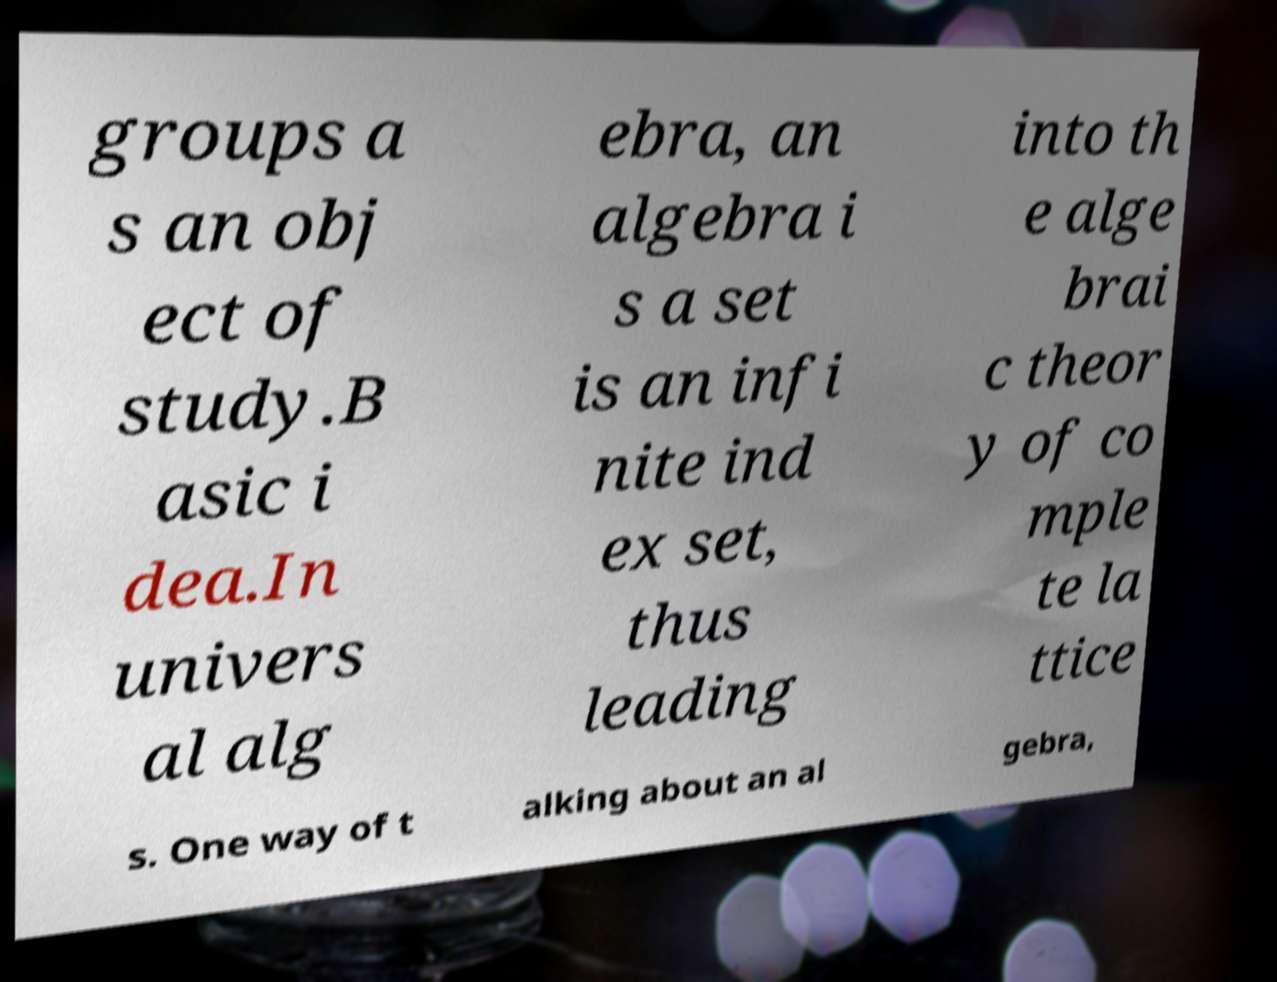Can you read and provide the text displayed in the image?This photo seems to have some interesting text. Can you extract and type it out for me? groups a s an obj ect of study.B asic i dea.In univers al alg ebra, an algebra i s a set is an infi nite ind ex set, thus leading into th e alge brai c theor y of co mple te la ttice s. One way of t alking about an al gebra, 